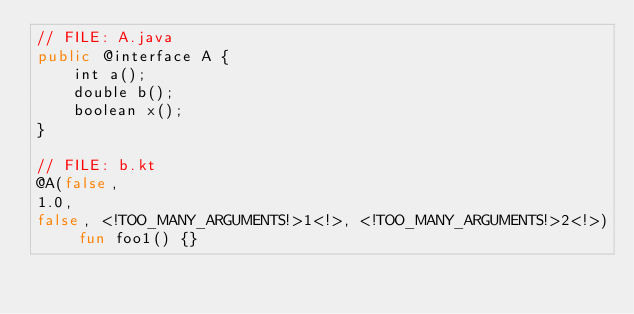<code> <loc_0><loc_0><loc_500><loc_500><_Kotlin_>// FILE: A.java
public @interface A {
    int a();
    double b();
    boolean x();
}

// FILE: b.kt
@A(false,
1.0,
false, <!TOO_MANY_ARGUMENTS!>1<!>, <!TOO_MANY_ARGUMENTS!>2<!>) fun foo1() {}
</code> 